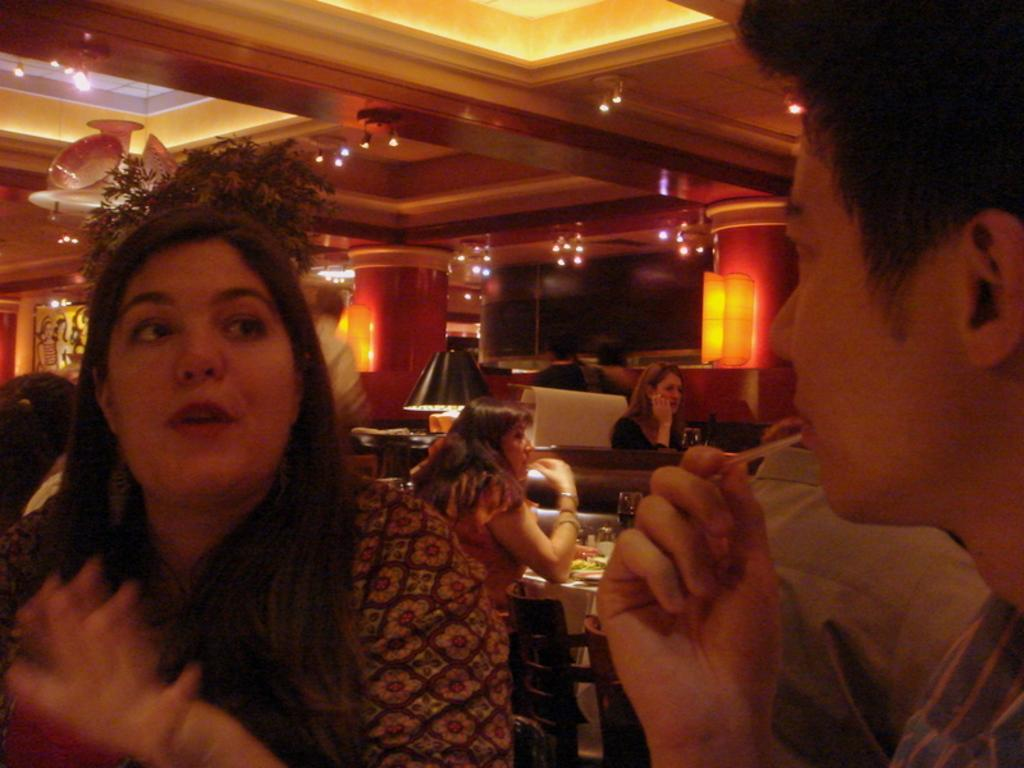What type of lighting is present in the image? There are electric lights in the image. What decorative items can be seen on the walls? There are wall hangings in the image. What type of lamp is on the bed? There is a bed lamp in the image. What furniture pieces are present in the room? There are tables and chairs in the image. What type of drinking vessels are visible? There are glass tumblers in the image. What is present that might be consumed? There is food in the image. How many persons are sitting on the chairs in the image? There is no information about the number of persons sitting on the chairs in the image? What type of fruit is being served on the plate in the image? There is no fruit mentioned or visible in the image. What time of day is it in the image, as indicated by the presence of a clock? There is no clock present in the image. 